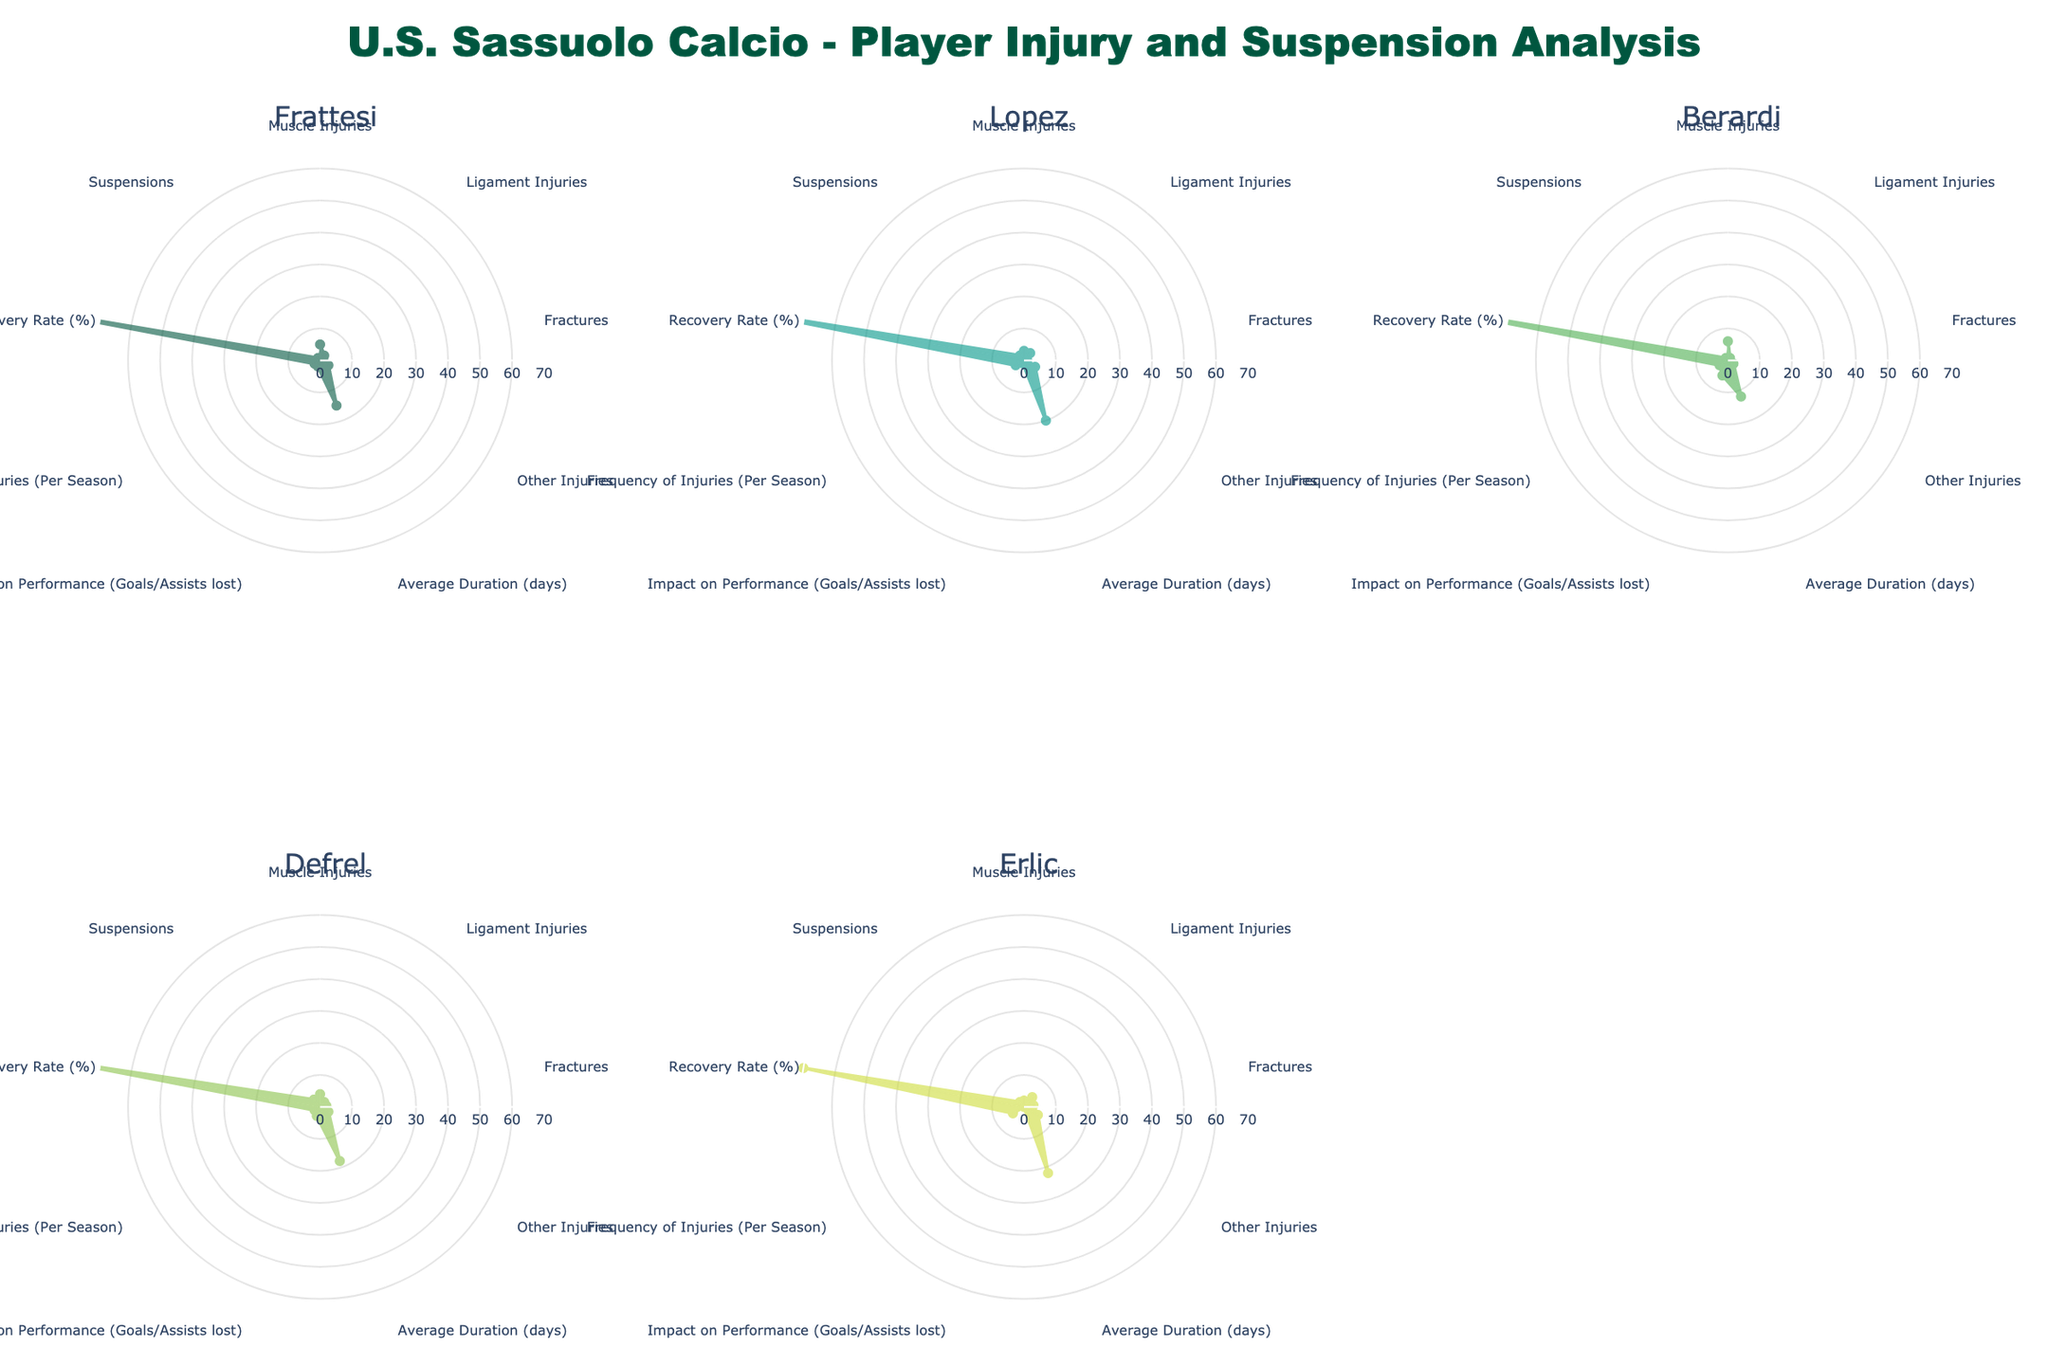What's the title of the figure? The title is usually prominently displayed at the top of the figure. In this case, it's mentioned in the `title` parameter when creating the figure layout.
Answer: U.S. Sassuolo Calcio - Player Injury and Suspension Analysis Can you list the metrics shown on the radar charts? By looking at the axes in each subplot, we can see the different metrics represented. They are 'Muscle Injuries,' 'Ligament Injuries,' 'Fractures,' 'Other Injuries,' 'Average Duration (days),' 'Impact on Performance (Goals/Assists lost),' 'Frequency of Injuries (Per Season),' 'Recovery Rate (%),' and 'Suspensions.'
Answer: Muscle Injuries, Ligament Injuries, Fractures, Other Injuries, Average Duration (days), Impact on Performance (Goals/Assists lost), Frequency of Injuries (Per Season), Recovery Rate (%), Suspensions Which player has the highest 'Recovery Rate (%)'? By inspecting the 'Recovery Rate (%)' value for each player across the subplots, we can identify the player with the highest value.
Answer: Berardi Who faced the most 'Fractures'? In the radar charts, we locate the 'Fractures' metric and compare the values for each player. Erlic has a value of 3 under 'Fractures.'
Answer: Erlic What is the average duration of absence for Frattesi and Lopez combined? To calculate the average, sum the 'Average Duration (days)' for Frattesi and Lopez and then divide by 2. Frattesi has 15 days, and Lopez has 20 days. Adding these gives 35 days, divide by 2 to get the average.
Answer: 17.5 days Who has been suspended the most? By looking at the 'Suspensions' metric for each player, we can identify the player with the highest count.
Answer: Defrel Which player has the lowest impact on performance in terms of goals/assists lost? Observing the 'Impact on Performance (Goals/Assists lost)' metric for each player, the player with the lowest value is identified.
Answer: Erlic Compare the frequency of injuries for Frattesi and Lopez. Who has had more injuries? Looking at the 'Frequency of Injuries (Per Season)' for both Frattesi and Lopez, Lopez has more injuries (3) compared to Frattesi (2).
Answer: Lopez Which type of injury is most common for Berardi? For Berardi, inspecting each type of injury shows that 'Muscle Injuries' (6) are the most common.
Answer: Muscle Injuries How does Defrel's recovery rate compare to Frattesi's recovery rate? Comparing the 'Recovery Rate (%)' for Defrel (80%) and Frattesi (90%), Frattesi's recovery rate is higher by 10%.
Answer: Frattesi's recovery rate is higher than Defrel's by 10% 